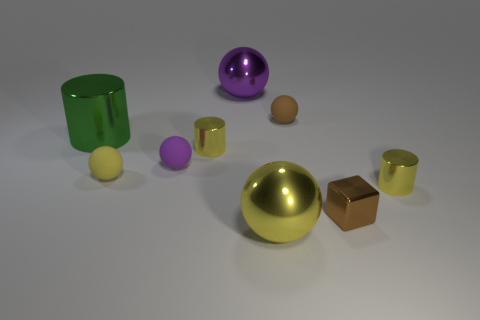Is there a small thing that has the same color as the small metallic cube?
Your answer should be compact. Yes. What is the color of the cube that is the same size as the purple matte ball?
Your response must be concise. Brown. Is there a yellow metallic cylinder that is right of the rubber object that is to the right of the big purple metallic ball?
Offer a very short reply. Yes. There is a big yellow sphere that is right of the tiny yellow sphere; what material is it?
Provide a short and direct response. Metal. Is the small yellow object on the right side of the brown block made of the same material as the small yellow cylinder behind the yellow matte sphere?
Keep it short and to the point. Yes. Are there an equal number of tiny yellow metal cylinders that are right of the brown rubber thing and tiny cylinders that are left of the big purple metal ball?
Make the answer very short. Yes. How many big green things are the same material as the big purple sphere?
Provide a short and direct response. 1. What shape is the object that is the same color as the small cube?
Make the answer very short. Sphere. What size is the brown thing that is behind the cylinder that is in front of the purple matte ball?
Keep it short and to the point. Small. Do the small yellow object that is in front of the tiny yellow matte ball and the small brown thing in front of the big green cylinder have the same shape?
Provide a short and direct response. No. 